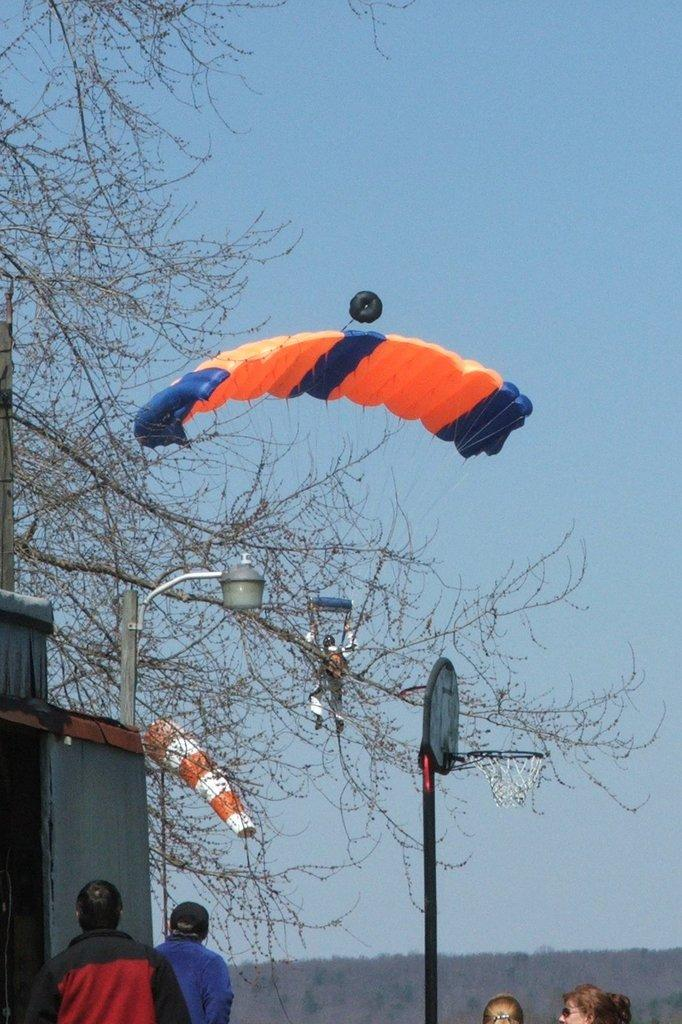What is the main object in the image? There is a parachute in the image. What can be seen in the image besides the parachute? There are people wearing clothes, a light pole, a basket pole, a building, trees, and the sky visible in the image. Can you describe the people in the image? The people in the image are wearing clothes. What type of structure is present in the image? There is a building in the image. What natural elements can be seen in the image? Trees are present in the image. What is visible in the background of the image? The sky is visible in the image. How many police officers are visible in the image? There are no police officers present in the image. Is there an earthquake happening in the image? There is no indication of an earthquake in the image. What shape is the parachute in the image? The parachute in the image is not a circle; it is typically a round or dome-shaped canopy. 